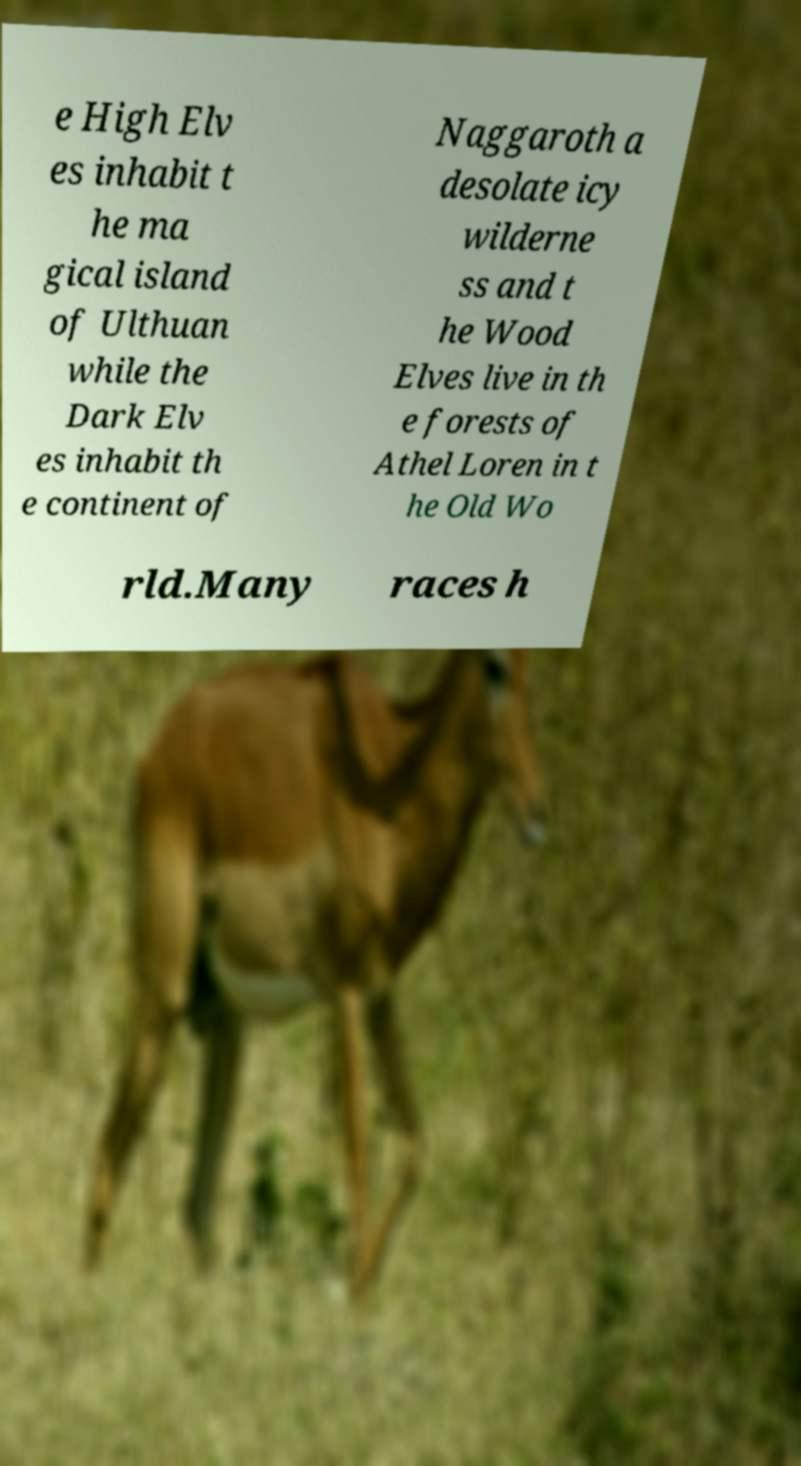For documentation purposes, I need the text within this image transcribed. Could you provide that? e High Elv es inhabit t he ma gical island of Ulthuan while the Dark Elv es inhabit th e continent of Naggaroth a desolate icy wilderne ss and t he Wood Elves live in th e forests of Athel Loren in t he Old Wo rld.Many races h 